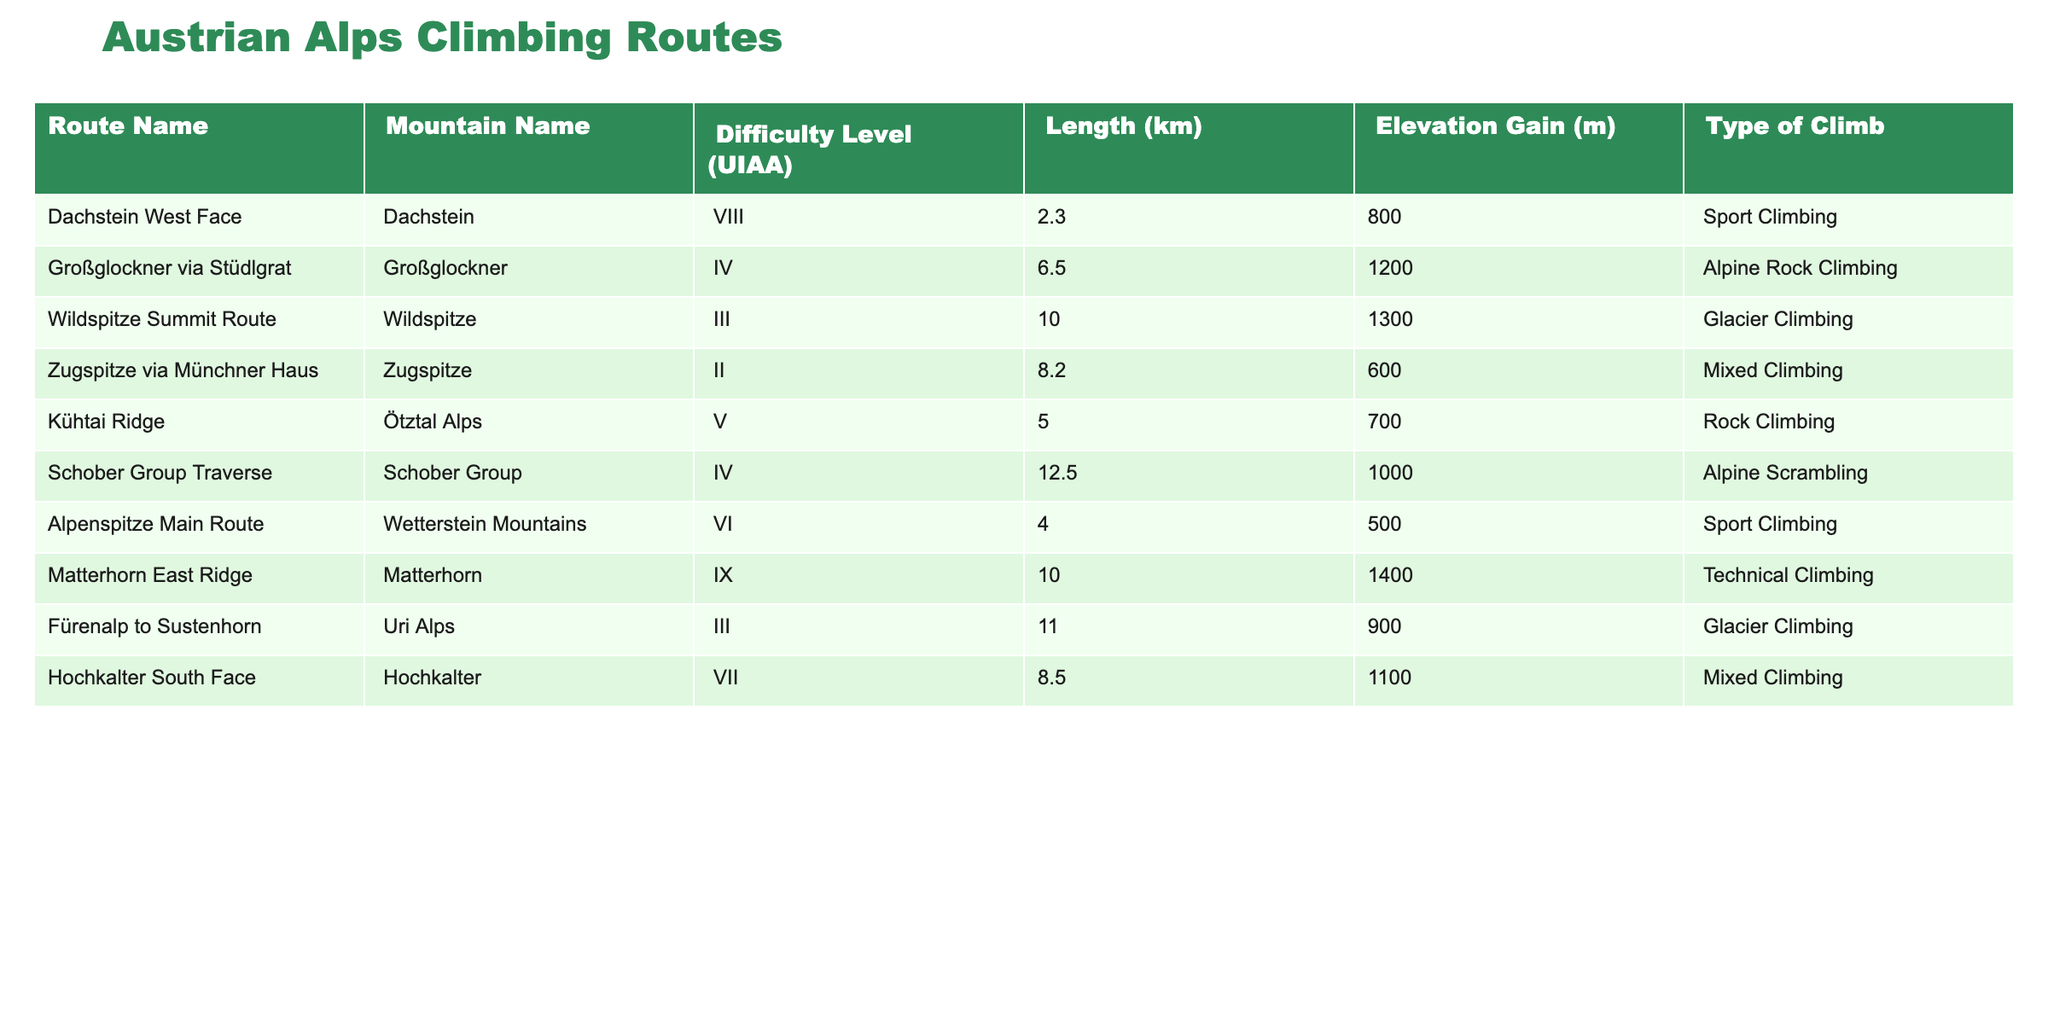What is the difficulty level of the Dachstein West Face route? The Dachstein West Face route is in the first row of the table, and its difficulty level is indicated in the "Difficulty Level (UIAA)" column. Upon checking this column, I see that it is listed as VIII.
Answer: VIII How many kilometers long is the Wildspitze Summit Route? The Wildspitze Summit Route is located in the third row, and the "Length (km)" column shows its length. It states that the length of this route is 10 km.
Answer: 10 km Which climbing type corresponds to the route with the highest elevation gain? The highest elevation gain can be found in the "Elevation Gain (m)" column. Checking the table, I see that the Matterhorn East Ridge has the highest elevation gain of 1400 m. The "Type of Climb" associated with this route is Technical Climbing.
Answer: Technical Climbing What is the average length of all climbing routes listed in the table? To find the average length, first sum all the lengths: 2.3 + 6.5 + 10 + 8.2 + 5 + 12.5 + 4 + 10 + 11 + 8.5 = 73. The number of routes is 10, so the average length is 73/10 = 7.3 km.
Answer: 7.3 km Is the Kühtai Ridge route classified as an alpine rock climbing route? By examining the "Type of Climb" for the Kühtai Ridge route located in the fifth row, I see it is categorized as Rock Climbing, not Alpine Rock Climbing. Therefore, the statement is false.
Answer: No What is the total elevation gain of the routes classified as Glacier Climbing? Looking at the "Type of Climb" column, the routes Fürenalp to Sustenhorn and Wildspitze Summit Route are categorized as Glacier Climbing, with elevation gains of 900 m and 1300 m, respectively. Adding these together, 900 + 1300 = 2200 m.
Answer: 2200 m Which route has a lower difficulty level: the Schober Group Traverse or the Hochkalter South Face? The Schober Group Traverse has a difficulty level of IV, while the Hochkalter South Face is rated VII. Since IV is lower than VII, the Schober Group Traverse has the lower difficulty level.
Answer: Schober Group Traverse How many routes have a difficulty level greater than VI? From the table, the routes with a difficulty level greater than VI are the Dachstein West Face (VIII) and the Matterhorn East Ridge (IX), which totals to 2 routes.
Answer: 2 